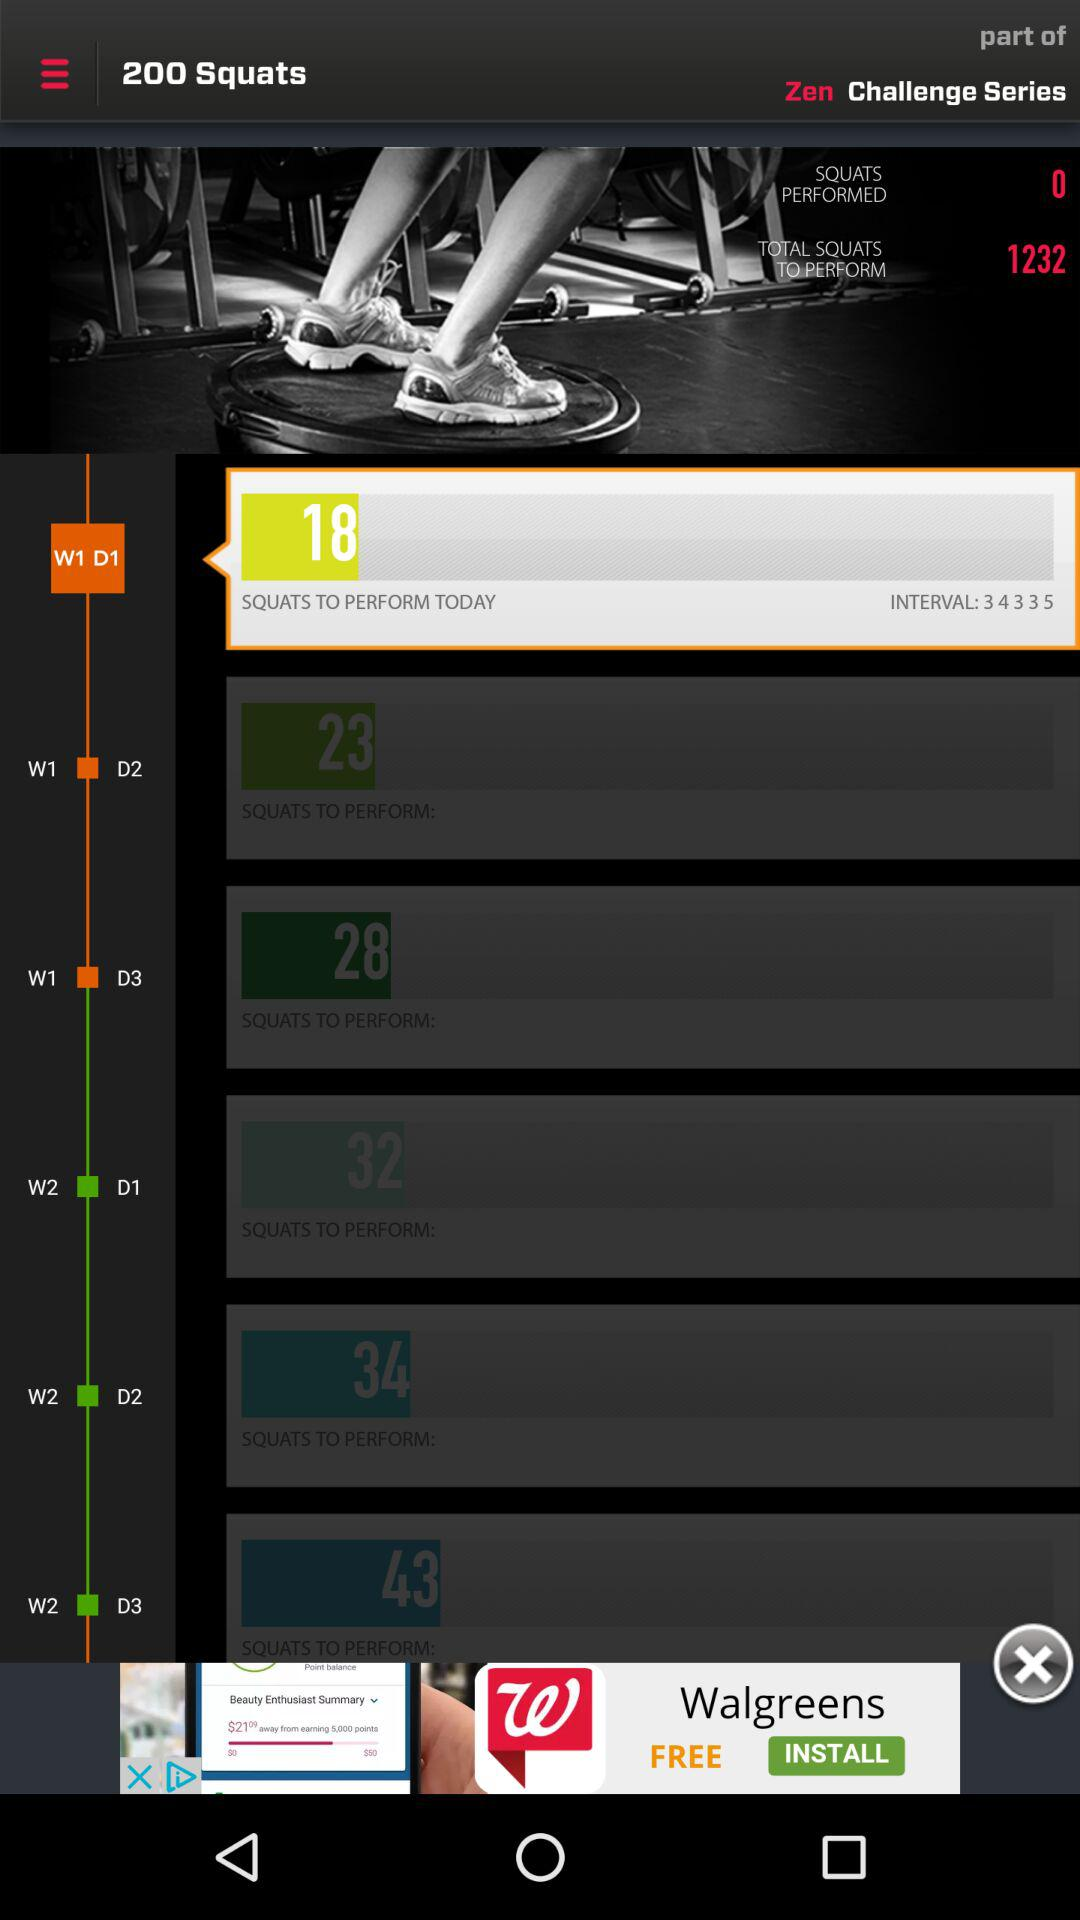What are the intervals given on day 1 of week 1?
When the provided information is insufficient, respond with <no answer>. <no answer> 